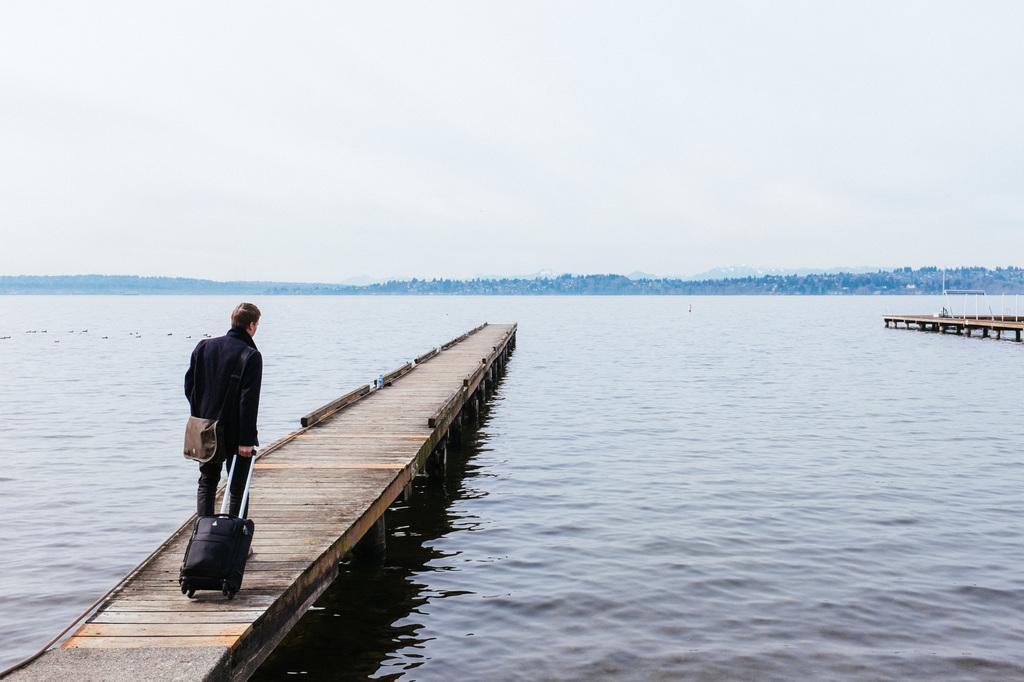Could you give a brief overview of what you see in this image? On the left side of the image we can see a person walking with trolley on the walkway bridge on the river. On the right side of the image there is a walkway bridge. In the background there is a water, trees, hills and sky. 